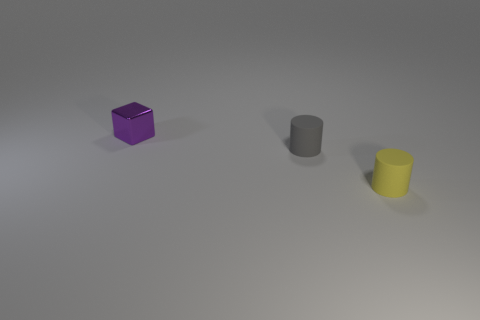Add 1 yellow matte objects. How many objects exist? 4 Subtract all yellow cylinders. How many cylinders are left? 1 Subtract 0 brown blocks. How many objects are left? 3 Subtract all cubes. How many objects are left? 2 Subtract 2 cylinders. How many cylinders are left? 0 Subtract all blue cubes. Subtract all blue spheres. How many cubes are left? 1 Subtract all green balls. How many yellow cylinders are left? 1 Subtract all cylinders. Subtract all big purple matte things. How many objects are left? 1 Add 1 tiny purple metal objects. How many tiny purple metal objects are left? 2 Add 3 small yellow matte objects. How many small yellow matte objects exist? 4 